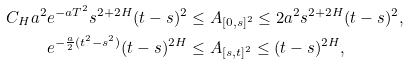<formula> <loc_0><loc_0><loc_500><loc_500>C _ { H } a ^ { 2 } e ^ { - a T ^ { 2 } } s ^ { 2 + 2 H } ( t - s ) ^ { 2 } & \leq A _ { [ 0 , s ] ^ { 2 } } \leq 2 a ^ { 2 } s ^ { 2 + 2 H } ( t - s ) ^ { 2 } , \\ e ^ { - \frac { a } 2 ( t ^ { 2 } - s ^ { 2 } ) } ( t - s ) ^ { 2 H } & \leq A _ { [ s , t ] ^ { 2 } } \leq ( t - s ) ^ { 2 H } ,</formula> 